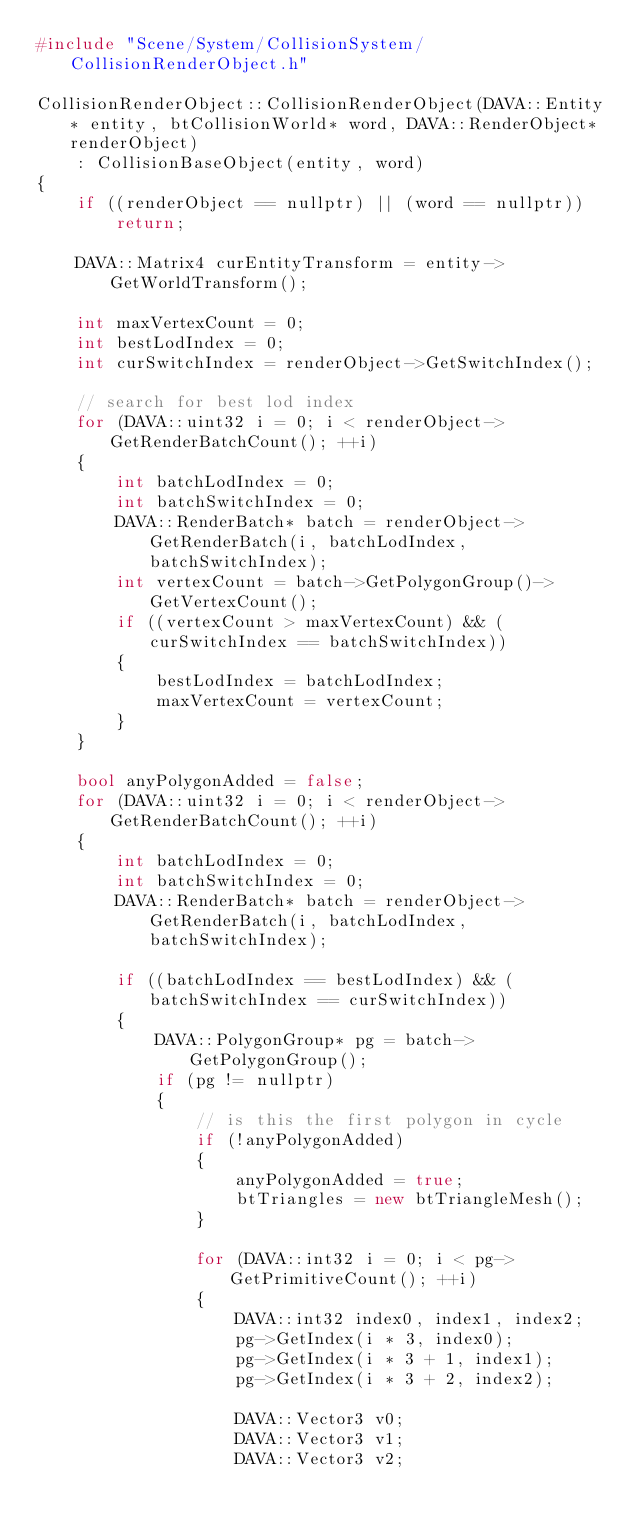Convert code to text. <code><loc_0><loc_0><loc_500><loc_500><_C++_>#include "Scene/System/CollisionSystem/CollisionRenderObject.h"

CollisionRenderObject::CollisionRenderObject(DAVA::Entity* entity, btCollisionWorld* word, DAVA::RenderObject* renderObject)
    : CollisionBaseObject(entity, word)
{
    if ((renderObject == nullptr) || (word == nullptr))
        return;

    DAVA::Matrix4 curEntityTransform = entity->GetWorldTransform();

    int maxVertexCount = 0;
    int bestLodIndex = 0;
    int curSwitchIndex = renderObject->GetSwitchIndex();

    // search for best lod index
    for (DAVA::uint32 i = 0; i < renderObject->GetRenderBatchCount(); ++i)
    {
        int batchLodIndex = 0;
        int batchSwitchIndex = 0;
        DAVA::RenderBatch* batch = renderObject->GetRenderBatch(i, batchLodIndex, batchSwitchIndex);
        int vertexCount = batch->GetPolygonGroup()->GetVertexCount();
        if ((vertexCount > maxVertexCount) && (curSwitchIndex == batchSwitchIndex))
        {
            bestLodIndex = batchLodIndex;
            maxVertexCount = vertexCount;
        }
    }

    bool anyPolygonAdded = false;
    for (DAVA::uint32 i = 0; i < renderObject->GetRenderBatchCount(); ++i)
    {
        int batchLodIndex = 0;
        int batchSwitchIndex = 0;
        DAVA::RenderBatch* batch = renderObject->GetRenderBatch(i, batchLodIndex, batchSwitchIndex);

        if ((batchLodIndex == bestLodIndex) && (batchSwitchIndex == curSwitchIndex))
        {
            DAVA::PolygonGroup* pg = batch->GetPolygonGroup();
            if (pg != nullptr)
            {
                // is this the first polygon in cycle
                if (!anyPolygonAdded)
                {
                    anyPolygonAdded = true;
                    btTriangles = new btTriangleMesh();
                }

                for (DAVA::int32 i = 0; i < pg->GetPrimitiveCount(); ++i)
                {
                    DAVA::int32 index0, index1, index2;
                    pg->GetIndex(i * 3, index0);
                    pg->GetIndex(i * 3 + 1, index1);
                    pg->GetIndex(i * 3 + 2, index2);

                    DAVA::Vector3 v0;
                    DAVA::Vector3 v1;
                    DAVA::Vector3 v2;</code> 